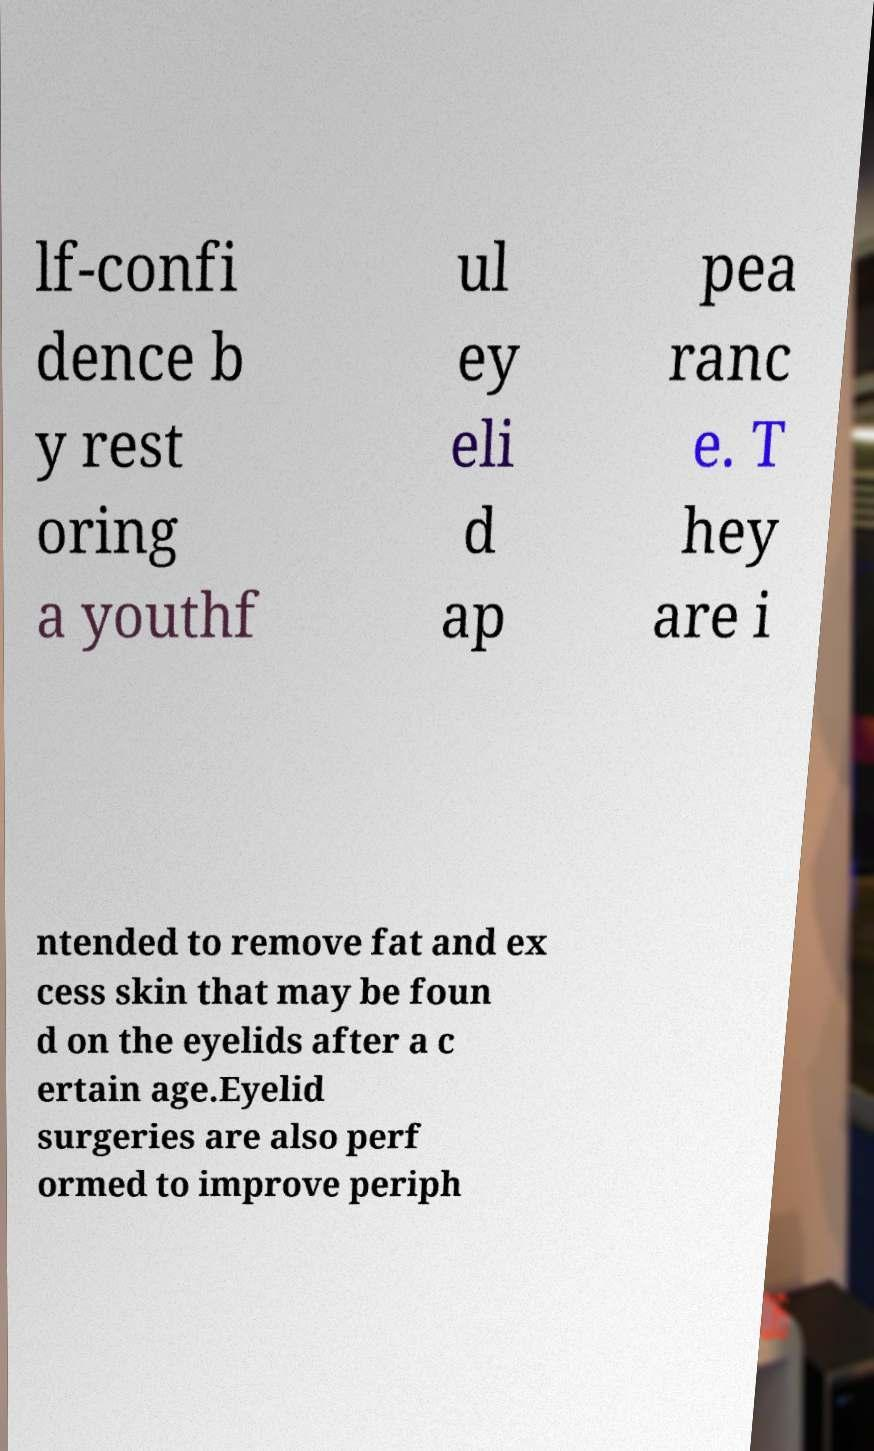There's text embedded in this image that I need extracted. Can you transcribe it verbatim? lf-confi dence b y rest oring a youthf ul ey eli d ap pea ranc e. T hey are i ntended to remove fat and ex cess skin that may be foun d on the eyelids after a c ertain age.Eyelid surgeries are also perf ormed to improve periph 